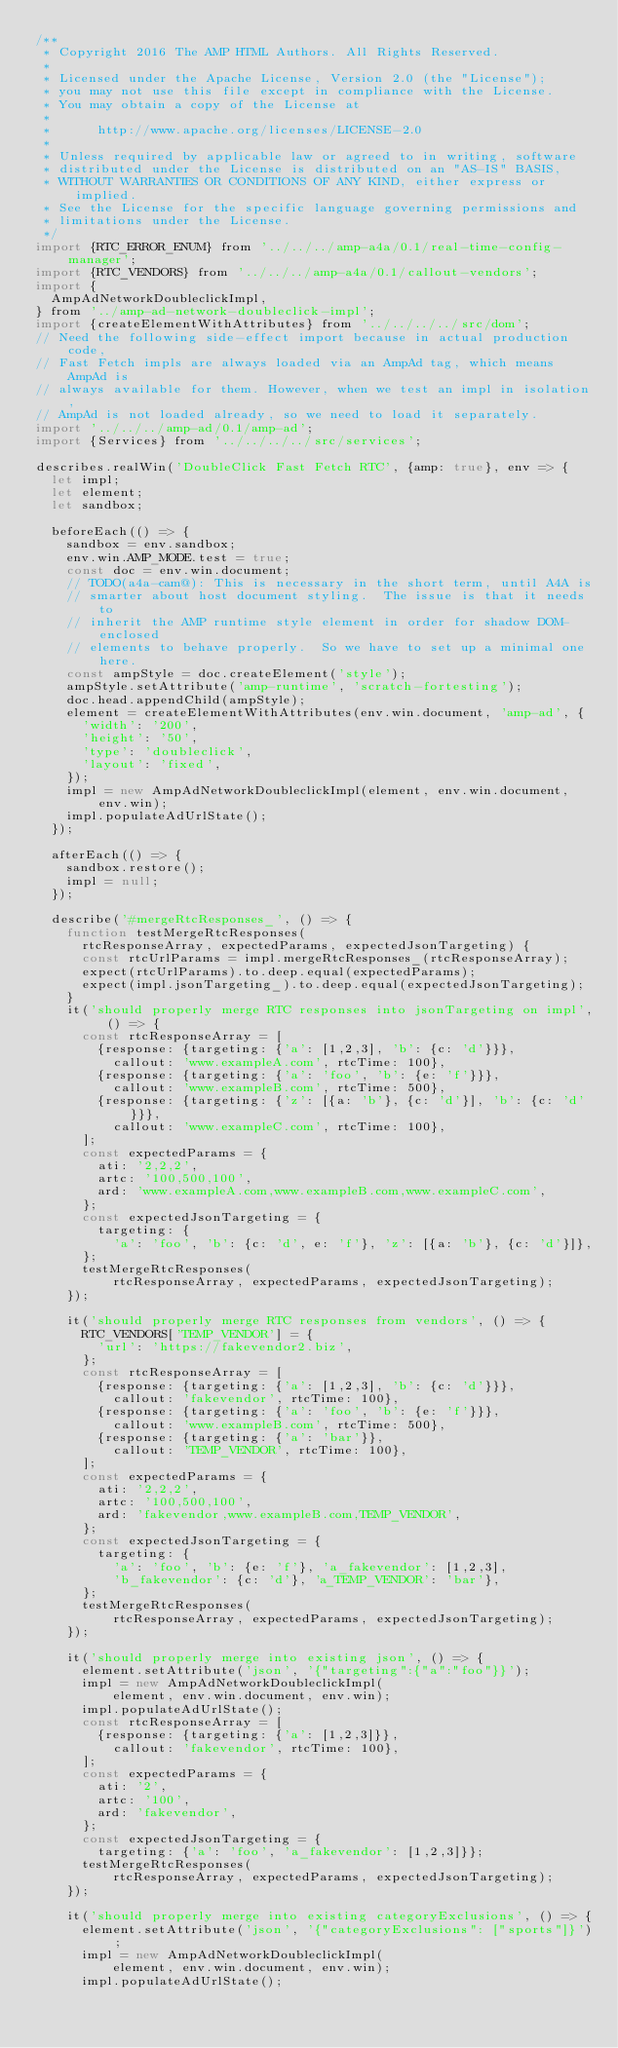Convert code to text. <code><loc_0><loc_0><loc_500><loc_500><_JavaScript_>/**
 * Copyright 2016 The AMP HTML Authors. All Rights Reserved.
 *
 * Licensed under the Apache License, Version 2.0 (the "License");
 * you may not use this file except in compliance with the License.
 * You may obtain a copy of the License at
 *
 *      http://www.apache.org/licenses/LICENSE-2.0
 *
 * Unless required by applicable law or agreed to in writing, software
 * distributed under the License is distributed on an "AS-IS" BASIS,
 * WITHOUT WARRANTIES OR CONDITIONS OF ANY KIND, either express or implied.
 * See the License for the specific language governing permissions and
 * limitations under the License.
 */
import {RTC_ERROR_ENUM} from '../../../amp-a4a/0.1/real-time-config-manager';
import {RTC_VENDORS} from '../../../amp-a4a/0.1/callout-vendors';
import {
  AmpAdNetworkDoubleclickImpl,
} from '../amp-ad-network-doubleclick-impl';
import {createElementWithAttributes} from '../../../../src/dom';
// Need the following side-effect import because in actual production code,
// Fast Fetch impls are always loaded via an AmpAd tag, which means AmpAd is
// always available for them. However, when we test an impl in isolation,
// AmpAd is not loaded already, so we need to load it separately.
import '../../../amp-ad/0.1/amp-ad';
import {Services} from '../../../../src/services';

describes.realWin('DoubleClick Fast Fetch RTC', {amp: true}, env => {
  let impl;
  let element;
  let sandbox;

  beforeEach(() => {
    sandbox = env.sandbox;
    env.win.AMP_MODE.test = true;
    const doc = env.win.document;
    // TODO(a4a-cam@): This is necessary in the short term, until A4A is
    // smarter about host document styling.  The issue is that it needs to
    // inherit the AMP runtime style element in order for shadow DOM-enclosed
    // elements to behave properly.  So we have to set up a minimal one here.
    const ampStyle = doc.createElement('style');
    ampStyle.setAttribute('amp-runtime', 'scratch-fortesting');
    doc.head.appendChild(ampStyle);
    element = createElementWithAttributes(env.win.document, 'amp-ad', {
      'width': '200',
      'height': '50',
      'type': 'doubleclick',
      'layout': 'fixed',
    });
    impl = new AmpAdNetworkDoubleclickImpl(element, env.win.document, env.win);
    impl.populateAdUrlState();
  });

  afterEach(() => {
    sandbox.restore();
    impl = null;
  });

  describe('#mergeRtcResponses_', () => {
    function testMergeRtcResponses(
      rtcResponseArray, expectedParams, expectedJsonTargeting) {
      const rtcUrlParams = impl.mergeRtcResponses_(rtcResponseArray);
      expect(rtcUrlParams).to.deep.equal(expectedParams);
      expect(impl.jsonTargeting_).to.deep.equal(expectedJsonTargeting);
    }
    it('should properly merge RTC responses into jsonTargeting on impl', () => {
      const rtcResponseArray = [
        {response: {targeting: {'a': [1,2,3], 'b': {c: 'd'}}},
          callout: 'www.exampleA.com', rtcTime: 100},
        {response: {targeting: {'a': 'foo', 'b': {e: 'f'}}},
          callout: 'www.exampleB.com', rtcTime: 500},
        {response: {targeting: {'z': [{a: 'b'}, {c: 'd'}], 'b': {c: 'd'}}},
          callout: 'www.exampleC.com', rtcTime: 100},
      ];
      const expectedParams = {
        ati: '2,2,2',
        artc: '100,500,100',
        ard: 'www.exampleA.com,www.exampleB.com,www.exampleC.com',
      };
      const expectedJsonTargeting = {
        targeting: {
          'a': 'foo', 'b': {c: 'd', e: 'f'}, 'z': [{a: 'b'}, {c: 'd'}]},
      };
      testMergeRtcResponses(
          rtcResponseArray, expectedParams, expectedJsonTargeting);
    });

    it('should properly merge RTC responses from vendors', () => {
      RTC_VENDORS['TEMP_VENDOR'] = {
        'url': 'https://fakevendor2.biz',
      };
      const rtcResponseArray = [
        {response: {targeting: {'a': [1,2,3], 'b': {c: 'd'}}},
          callout: 'fakevendor', rtcTime: 100},
        {response: {targeting: {'a': 'foo', 'b': {e: 'f'}}},
          callout: 'www.exampleB.com', rtcTime: 500},
        {response: {targeting: {'a': 'bar'}},
          callout: 'TEMP_VENDOR', rtcTime: 100},
      ];
      const expectedParams = {
        ati: '2,2,2',
        artc: '100,500,100',
        ard: 'fakevendor,www.exampleB.com,TEMP_VENDOR',
      };
      const expectedJsonTargeting = {
        targeting: {
          'a': 'foo', 'b': {e: 'f'}, 'a_fakevendor': [1,2,3],
          'b_fakevendor': {c: 'd'}, 'a_TEMP_VENDOR': 'bar'},
      };
      testMergeRtcResponses(
          rtcResponseArray, expectedParams, expectedJsonTargeting);
    });

    it('should properly merge into existing json', () => {
      element.setAttribute('json', '{"targeting":{"a":"foo"}}');
      impl = new AmpAdNetworkDoubleclickImpl(
          element, env.win.document, env.win);
      impl.populateAdUrlState();
      const rtcResponseArray = [
        {response: {targeting: {'a': [1,2,3]}},
          callout: 'fakevendor', rtcTime: 100},
      ];
      const expectedParams = {
        ati: '2',
        artc: '100',
        ard: 'fakevendor',
      };
      const expectedJsonTargeting = {
        targeting: {'a': 'foo', 'a_fakevendor': [1,2,3]}};
      testMergeRtcResponses(
          rtcResponseArray, expectedParams, expectedJsonTargeting);
    });

    it('should properly merge into existing categoryExclusions', () => {
      element.setAttribute('json', '{"categoryExclusions": ["sports"]}');
      impl = new AmpAdNetworkDoubleclickImpl(
          element, env.win.document, env.win);
      impl.populateAdUrlState();</code> 